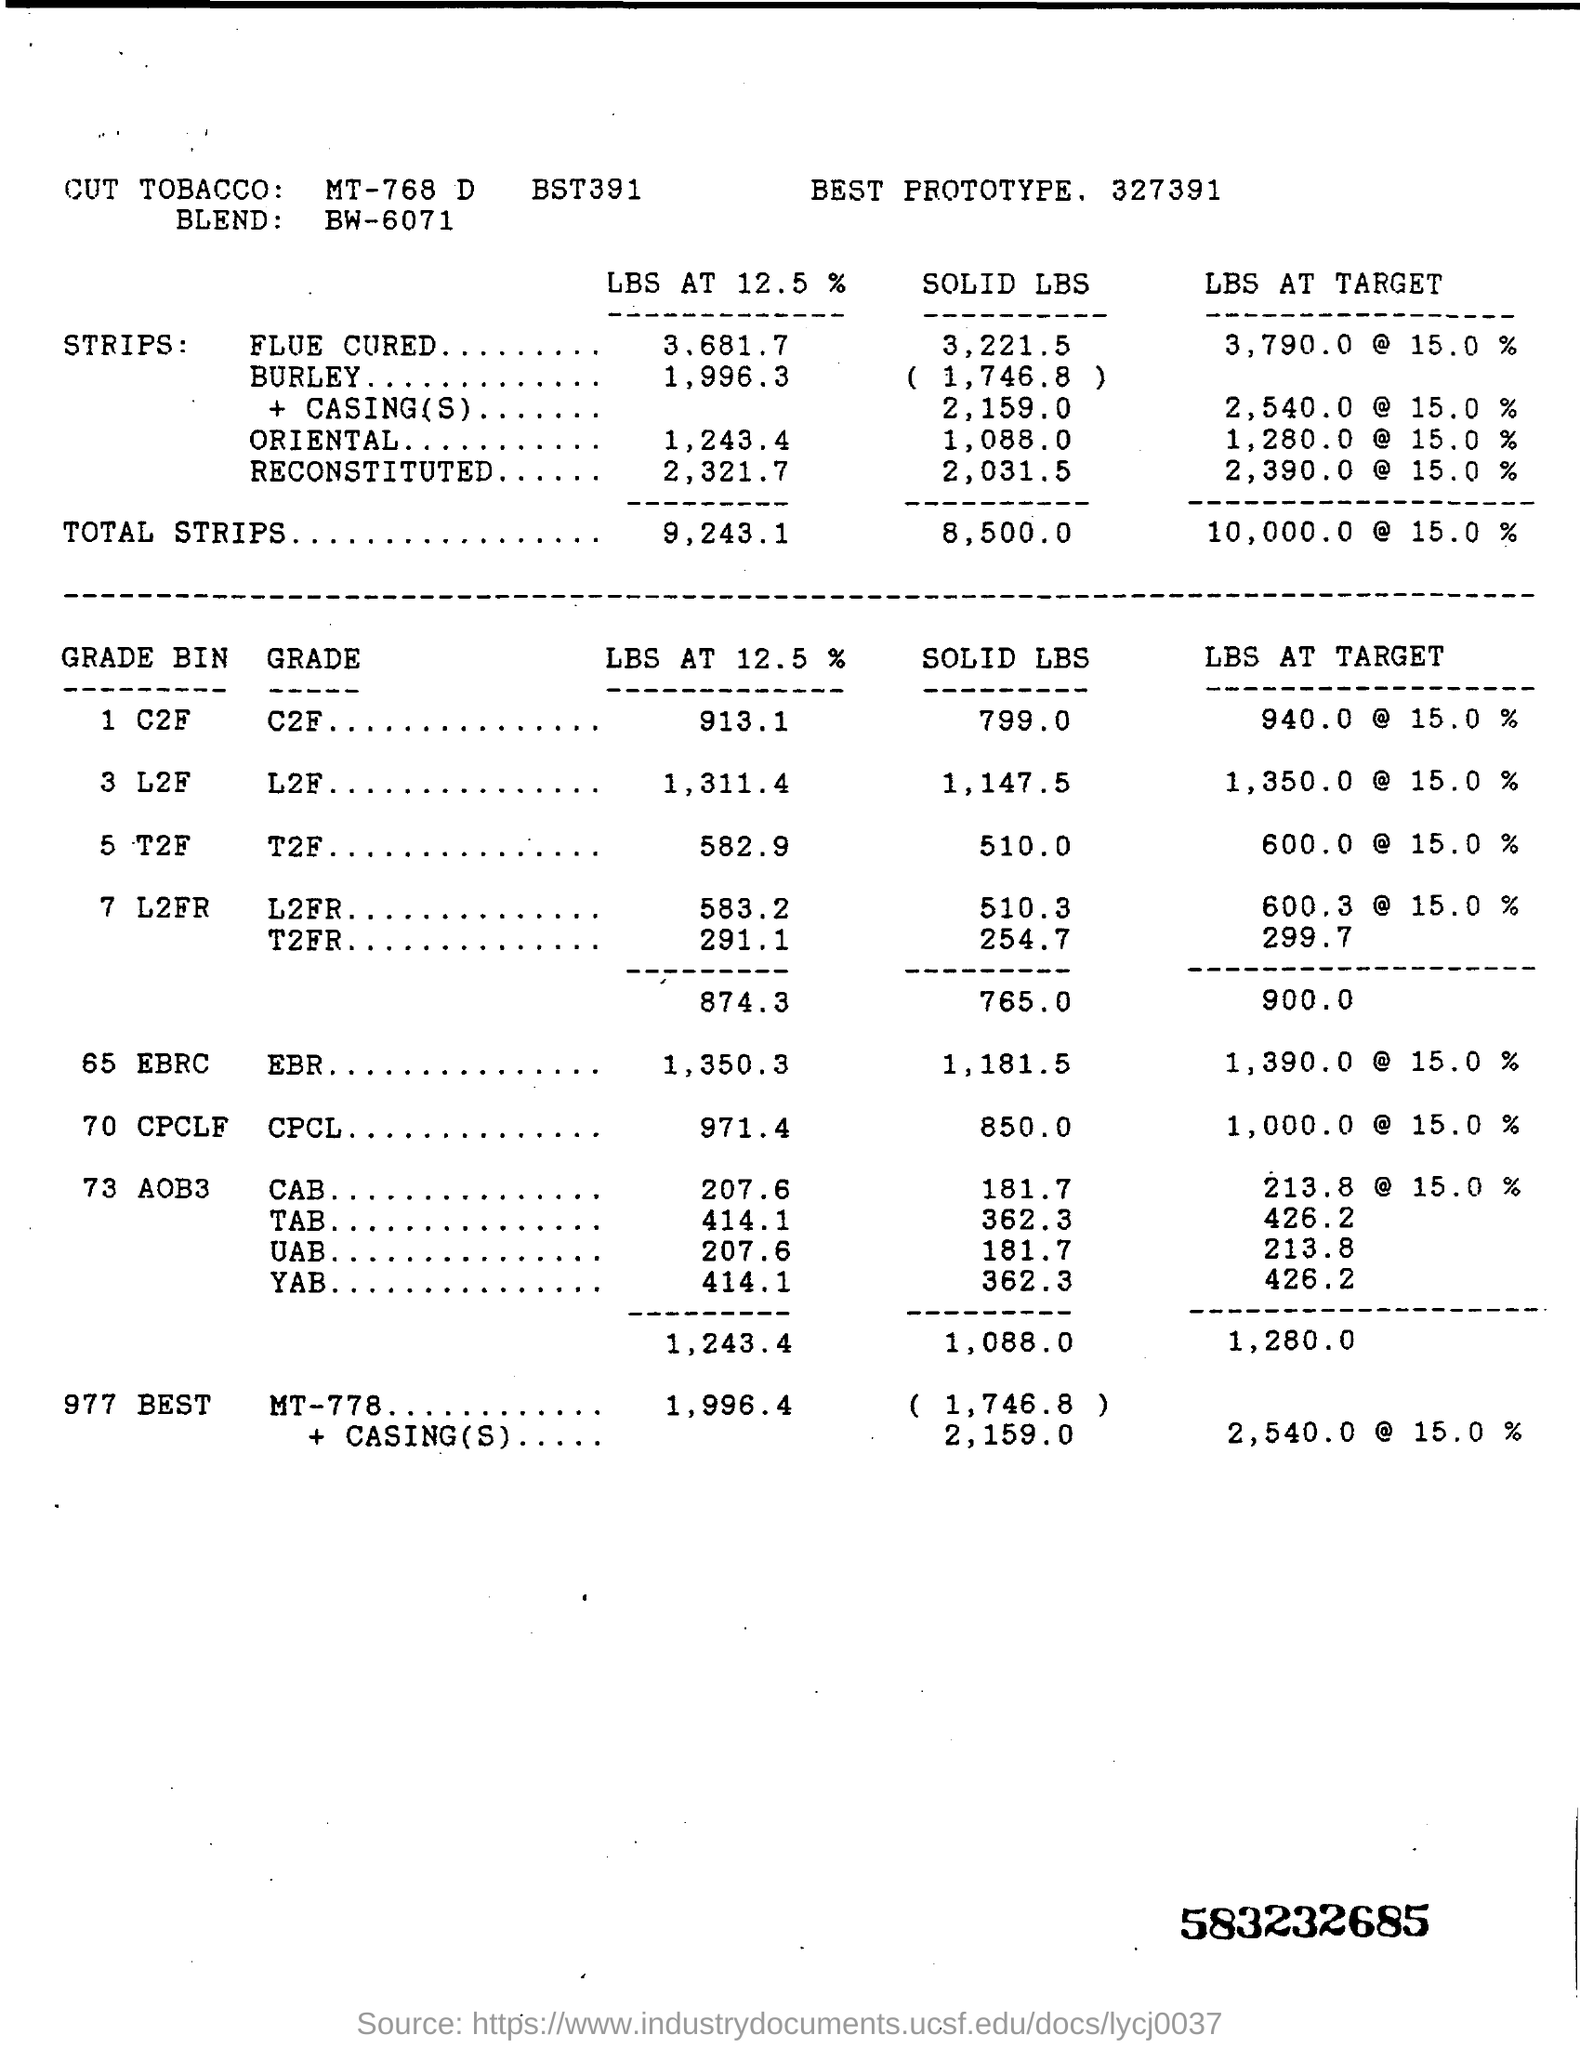What is the Best Prototype mentioned?
Make the answer very short. 327391. What is the BLEND mentioned?
Make the answer very short. BW-6071. What is the LBS AT TARGET of TOTAL STRIPS?
Ensure brevity in your answer.  10,000.0 @ 15.0 %. What is the SOLID LBS of T2F GRADE?
Provide a short and direct response. 510. 